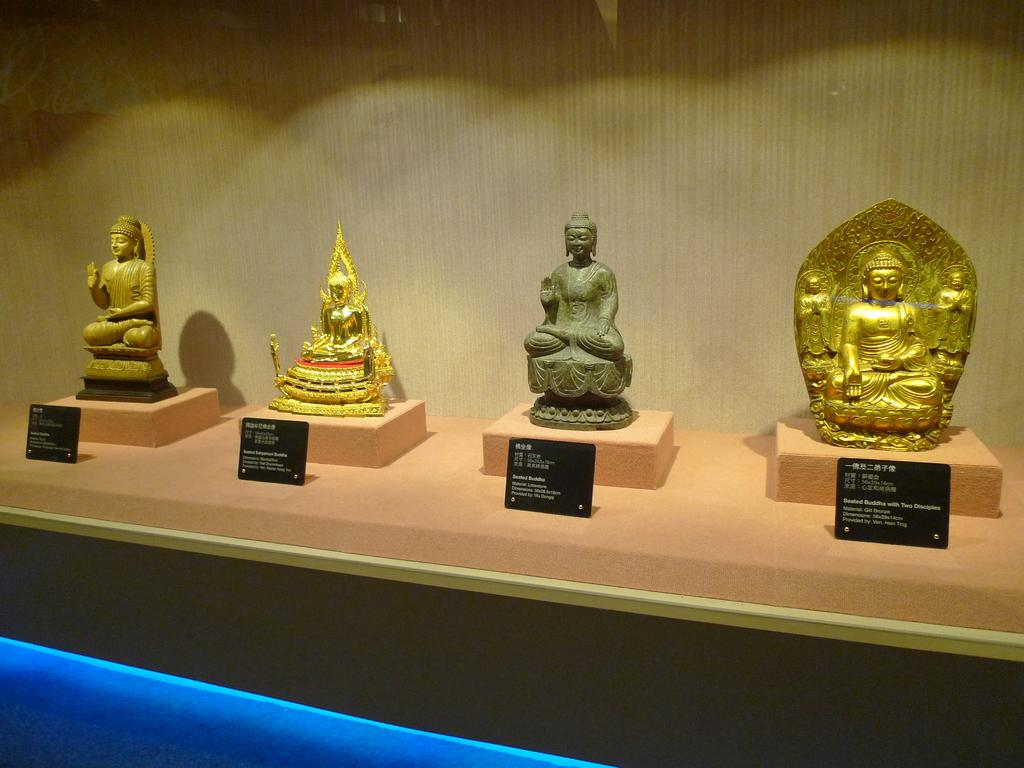How many idols are present in the image? There are four idols in the image. How are the idols arranged in relation to each other? The idols are arranged side by side. What is placed in front of the idols? There are boards with text in front of the idols. What can be seen in the background of the image? There is a wall in the background of the image. How does the glue hold the idols together in the image? There is no glue present in the image, and the idols are not held together. 